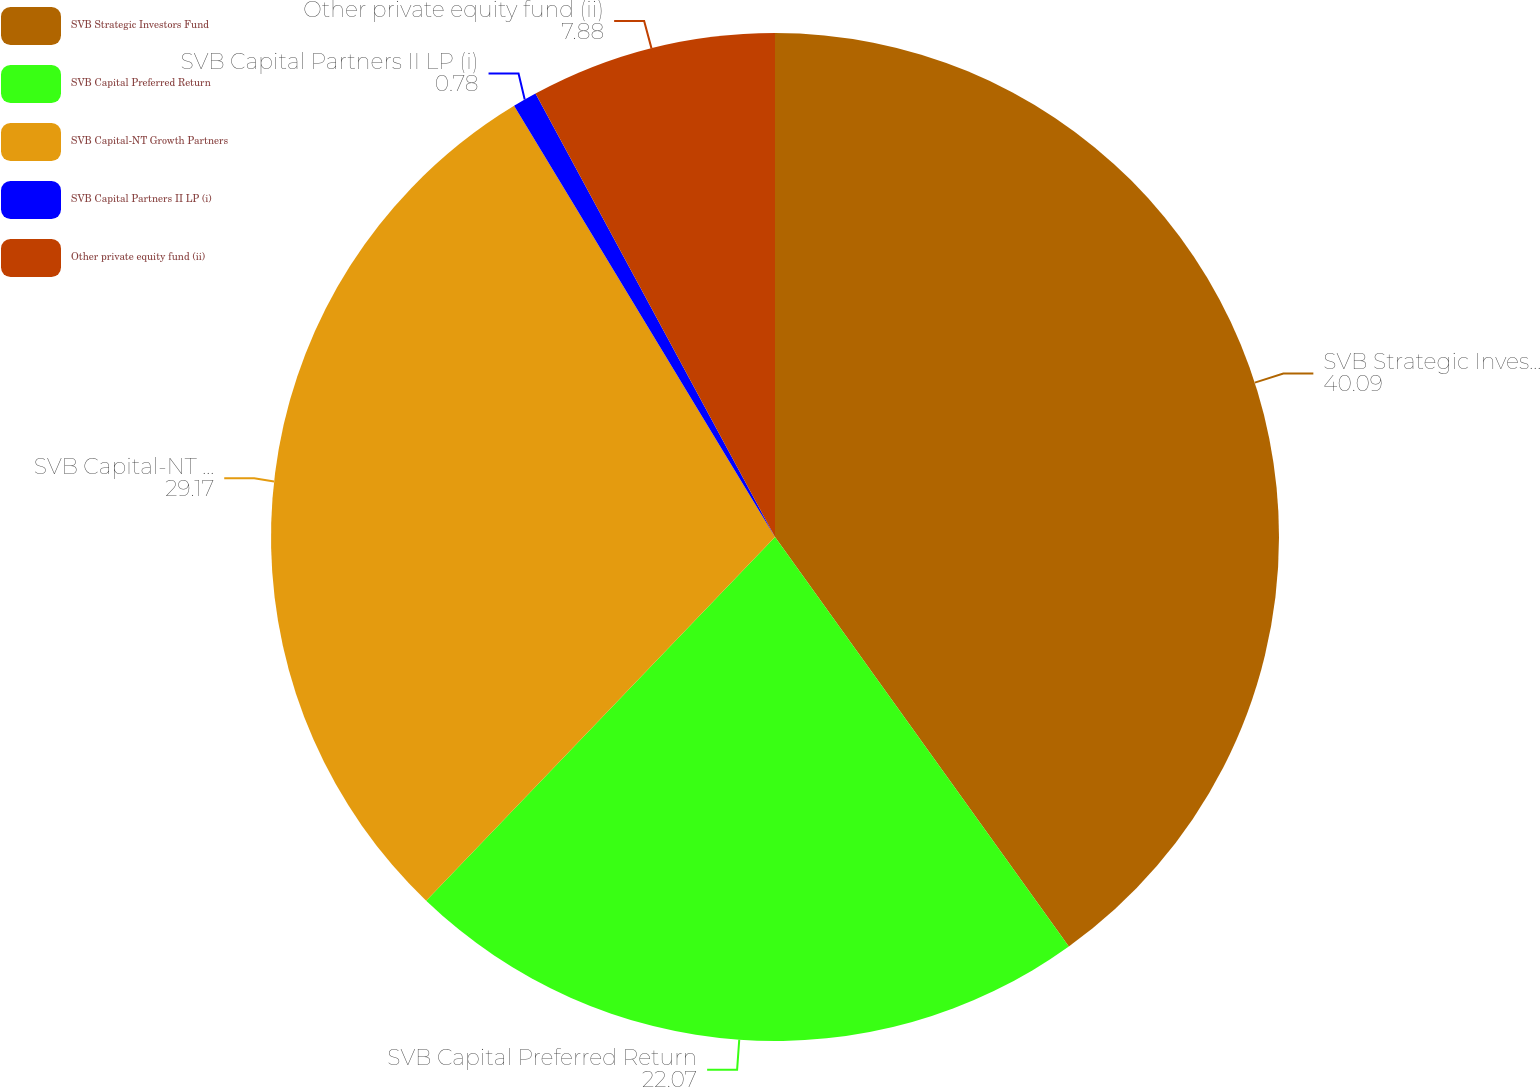Convert chart. <chart><loc_0><loc_0><loc_500><loc_500><pie_chart><fcel>SVB Strategic Investors Fund<fcel>SVB Capital Preferred Return<fcel>SVB Capital-NT Growth Partners<fcel>SVB Capital Partners II LP (i)<fcel>Other private equity fund (ii)<nl><fcel>40.09%<fcel>22.07%<fcel>29.17%<fcel>0.78%<fcel>7.88%<nl></chart> 